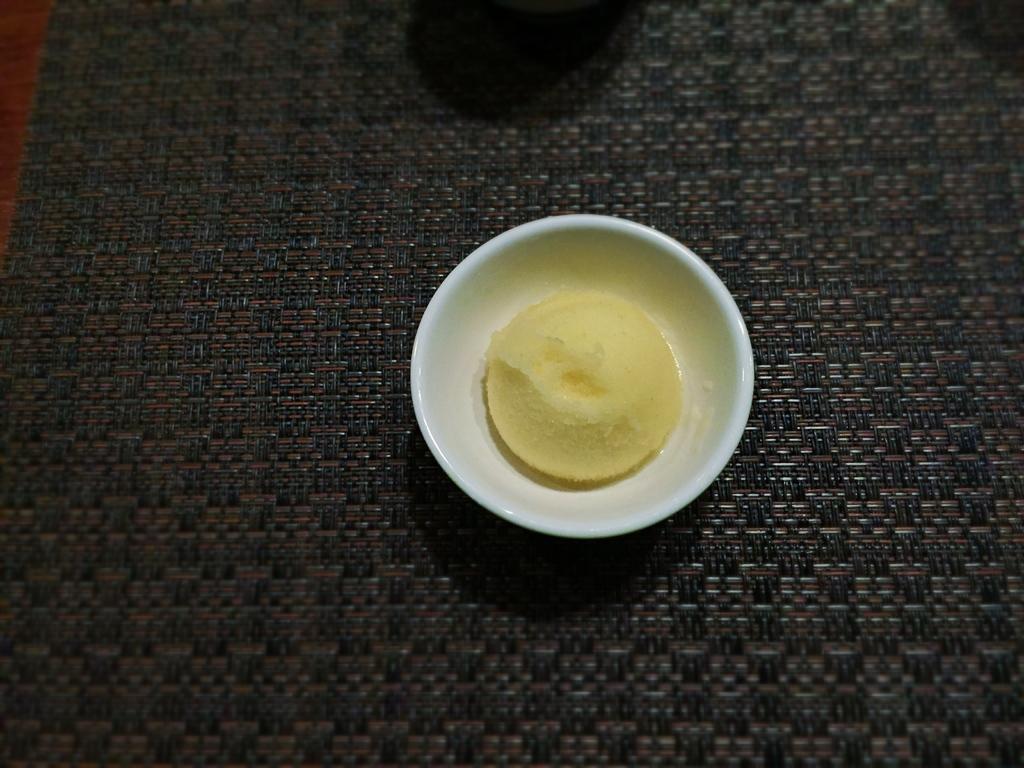Please provide a concise description of this image. In the image there is an ice cream cup on a carpet. 